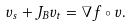Convert formula to latex. <formula><loc_0><loc_0><loc_500><loc_500>v _ { s } + J _ { B } v _ { t } = \nabla f \circ v .</formula> 